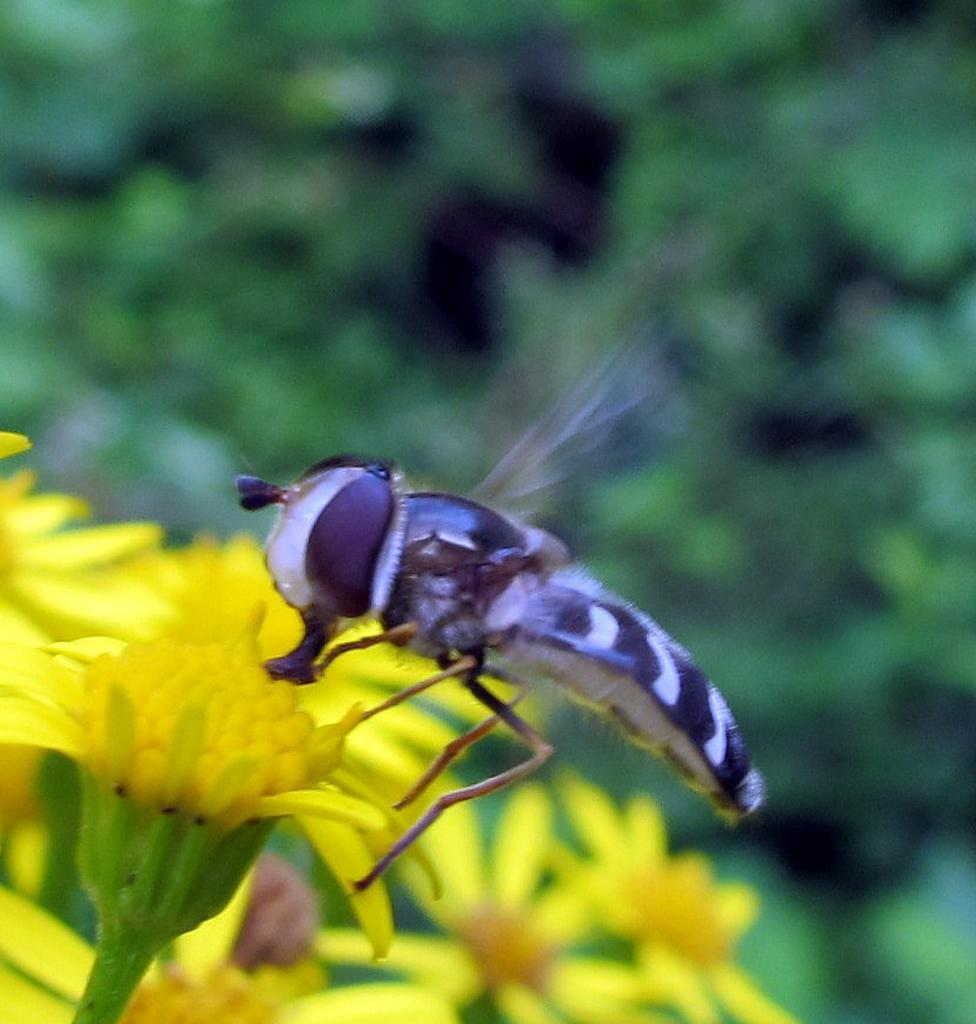What type of creature can be seen in the image? There is an insect in the image. What other objects or living organisms are present in the image? There are flowers in the image. Can you describe the background of the image? The background of the image is blurred. What type of wrench is being used to answer the insect's questions in the image? There is no wrench or any indication of questions being asked in the image. 